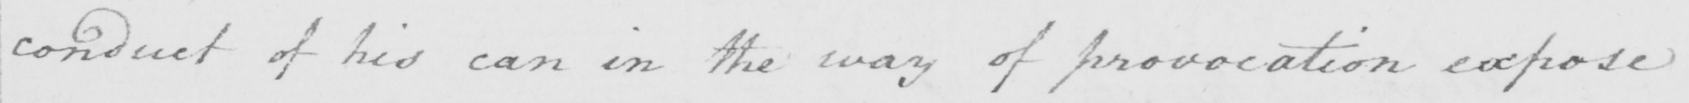What is written in this line of handwriting? conduct of his can in the way of provocation expose 